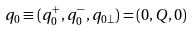Convert formula to latex. <formula><loc_0><loc_0><loc_500><loc_500>q _ { 0 } \equiv ( q _ { 0 } ^ { + } , q _ { 0 } ^ { - } , q _ { 0 \perp } ) = ( 0 , Q , 0 )</formula> 